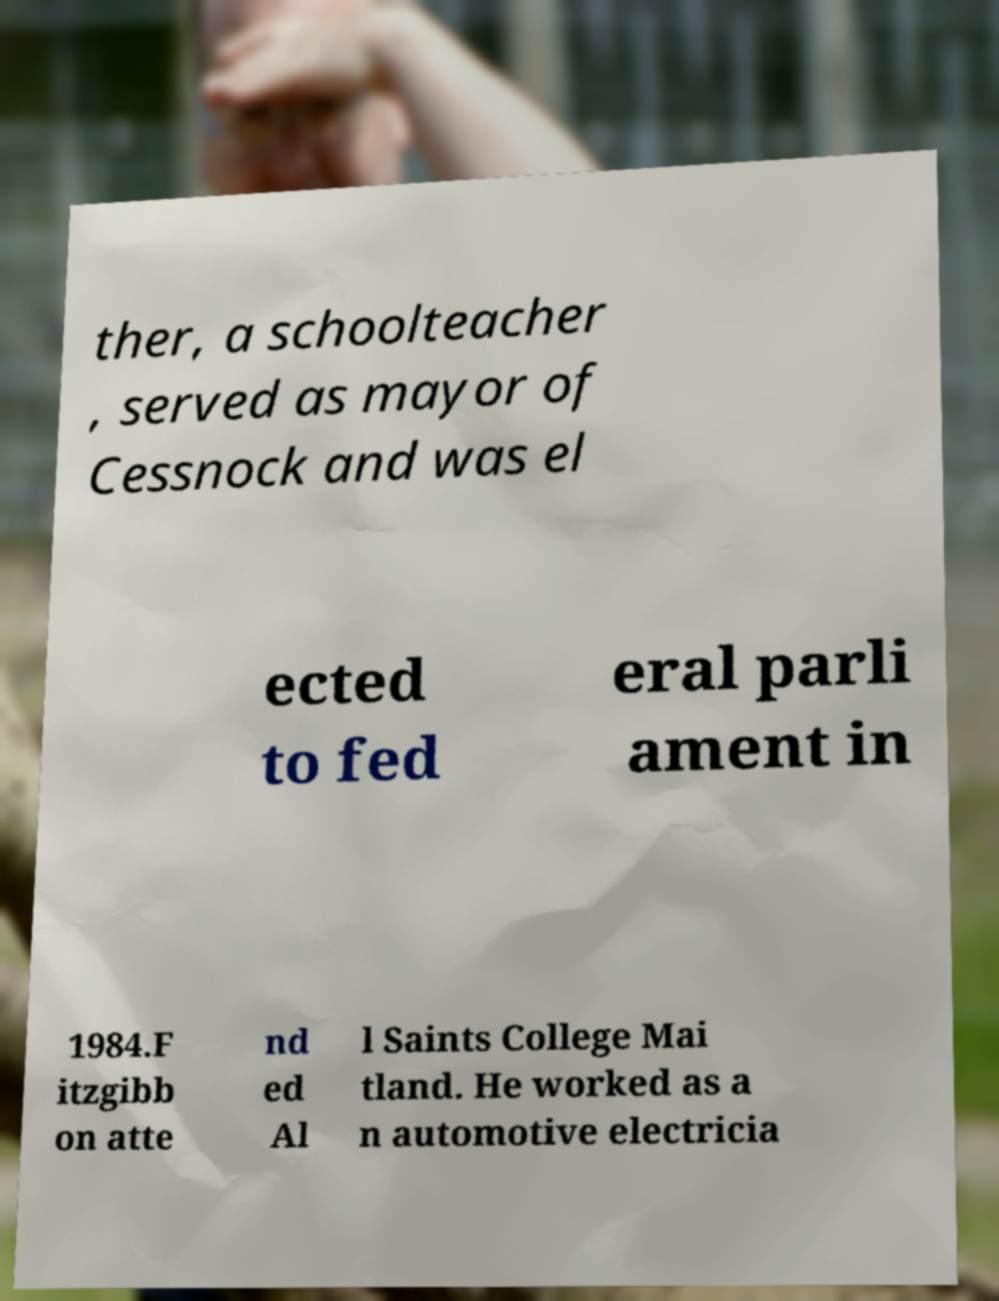Please identify and transcribe the text found in this image. ther, a schoolteacher , served as mayor of Cessnock and was el ected to fed eral parli ament in 1984.F itzgibb on atte nd ed Al l Saints College Mai tland. He worked as a n automotive electricia 